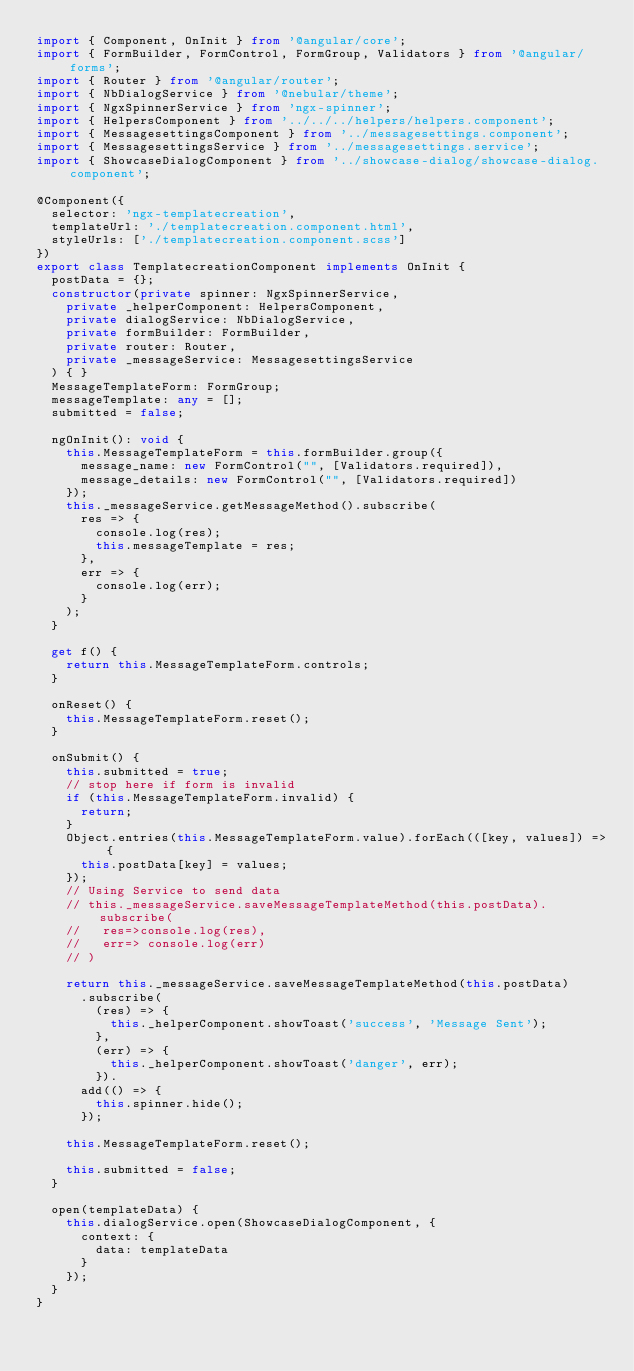Convert code to text. <code><loc_0><loc_0><loc_500><loc_500><_TypeScript_>import { Component, OnInit } from '@angular/core';
import { FormBuilder, FormControl, FormGroup, Validators } from '@angular/forms';
import { Router } from '@angular/router';
import { NbDialogService } from '@nebular/theme';
import { NgxSpinnerService } from 'ngx-spinner';
import { HelpersComponent } from '../../../helpers/helpers.component';
import { MessagesettingsComponent } from '../messagesettings.component';
import { MessagesettingsService } from '../messagesettings.service';
import { ShowcaseDialogComponent } from '../showcase-dialog/showcase-dialog.component';

@Component({
  selector: 'ngx-templatecreation',
  templateUrl: './templatecreation.component.html',
  styleUrls: ['./templatecreation.component.scss']
})
export class TemplatecreationComponent implements OnInit {
  postData = {};
  constructor(private spinner: NgxSpinnerService,
    private _helperComponent: HelpersComponent,
    private dialogService: NbDialogService,
    private formBuilder: FormBuilder,
    private router: Router,
    private _messageService: MessagesettingsService
  ) { }
  MessageTemplateForm: FormGroup;
  messageTemplate: any = [];
  submitted = false;

  ngOnInit(): void {
    this.MessageTemplateForm = this.formBuilder.group({
      message_name: new FormControl("", [Validators.required]),
      message_details: new FormControl("", [Validators.required])
    });
    this._messageService.getMessageMethod().subscribe(
      res => {
        console.log(res);
        this.messageTemplate = res;
      },
      err => {
        console.log(err);
      }
    );
  }

  get f() {
    return this.MessageTemplateForm.controls;
  }

  onReset() {
    this.MessageTemplateForm.reset();
  }

  onSubmit() {
    this.submitted = true;
    // stop here if form is invalid
    if (this.MessageTemplateForm.invalid) {
      return;
    }
    Object.entries(this.MessageTemplateForm.value).forEach(([key, values]) => {
      this.postData[key] = values;
    });
    // Using Service to send data
    // this._messageService.saveMessageTemplateMethod(this.postData).subscribe(
    //   res=>console.log(res),
    //   err=> console.log(err)
    // )

    return this._messageService.saveMessageTemplateMethod(this.postData)
      .subscribe(
        (res) => {
          this._helperComponent.showToast('success', 'Message Sent');
        },
        (err) => {
          this._helperComponent.showToast('danger', err);
        }).
      add(() => {
        this.spinner.hide();
      });

    this.MessageTemplateForm.reset();

    this.submitted = false;
  }

  open(templateData) {
    this.dialogService.open(ShowcaseDialogComponent, {
      context: {
        data: templateData
      }
    });
  }
}
</code> 